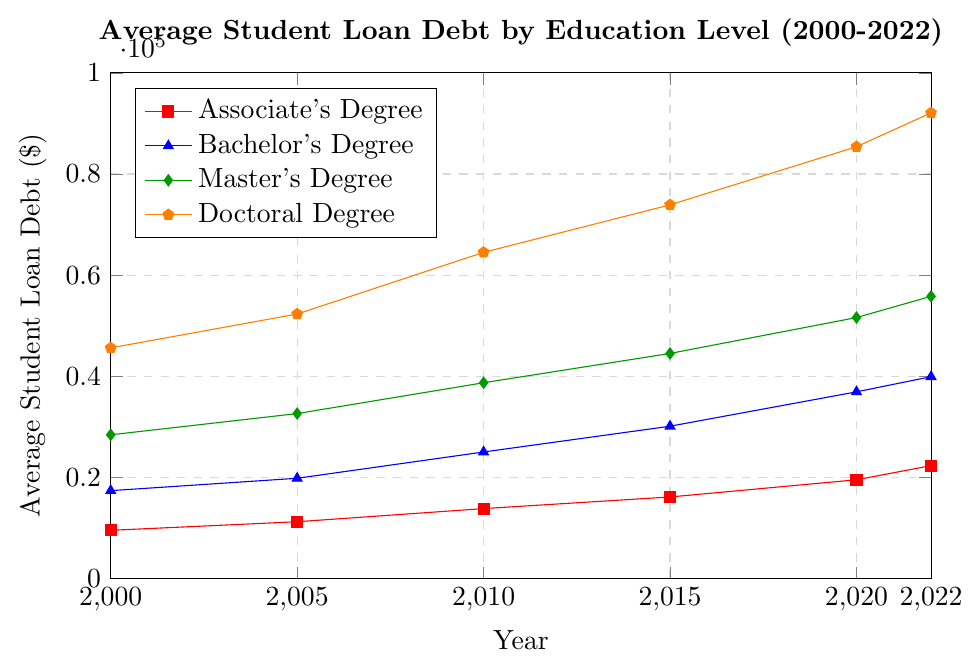What trend can be observed for student loan debt for an Associate’s Degree from 2000 to 2022? The plot for the Associate’s Degree, shown by the red line with square markers, shows an overall upward trend in student loan debt from 2000 to 2022.
Answer: Increasing Which education level had the highest average student loan debt in 2010? The plot shows that in 2010, the Doctoral Degree (orange line with pentagon markers) had the highest average student loan debt as it is the tallest line among all education levels for that year.
Answer: Doctoral Degree How much did the average student loan debt for a Master's Degree change from 2000 to 2022? The average student loan debt for a Master's Degree in 2000 was $28,400 and in 2022 it was $55,800. The change is calculated as $55,800 - $28,400 = $27,400.
Answer: $27,400 In which year did the average student loan debt for Bachelor’s Degree surpass $30,000? The plot shows the blue line (Bachelor's Degree) surpassing the $30,000 level between the years 2010 and 2015, exactly at 2015.
Answer: 2015 Did the average student loan debt for a Doctoral Degree ever decrease within the given period? By examining the orange line with pentagon markers on the plot, it is clear that the average student loan debt for a Doctoral Degree consistently increased every year from 2000 to 2022. There are no instances of a decrease.
Answer: No In 2022, which degree had the second highest average student loan debt? For 2022, visually examining the height of the lines, the Doctoral Degree had the highest average student loan debt, followed by the Master's Degree (green diamond markers).
Answer: Master’s Degree What was the combined average student loan debt for an Associate’s and Bachelor’s Degree in 2020? The values for 2020 are $19,500 for Associate’s Degree and $36,900 for Bachelor’s Degree. The combined amount is $19,500 + $36,900 = $56,400.
Answer: $56,400 Compare the average student loan debt between Bachelor’s and Doctoral Degrees in 2000. By how much did Doctoral Degree debt exceed Bachelor’s Degree debt? In 2000, the average student loan debt for a Bachelor’s Degree was $17,350, and for a Doctoral Degree, it was $45,600. The Doctoral Degree debt exceeded the Bachelor's Degree debt by $45,600 - $17,350 = $28,250.
Answer: $28,250 